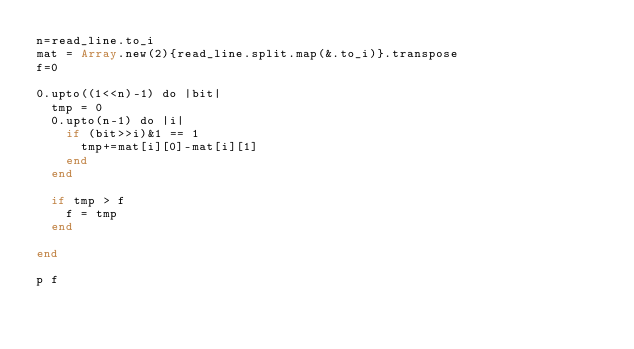<code> <loc_0><loc_0><loc_500><loc_500><_Crystal_>n=read_line.to_i
mat = Array.new(2){read_line.split.map(&.to_i)}.transpose
f=0

0.upto((1<<n)-1) do |bit|
  tmp = 0
  0.upto(n-1) do |i|
  	if (bit>>i)&1 == 1
      tmp+=mat[i][0]-mat[i][1]
    end
  end
  
  if tmp > f
    f = tmp
  end
  
end

p f</code> 